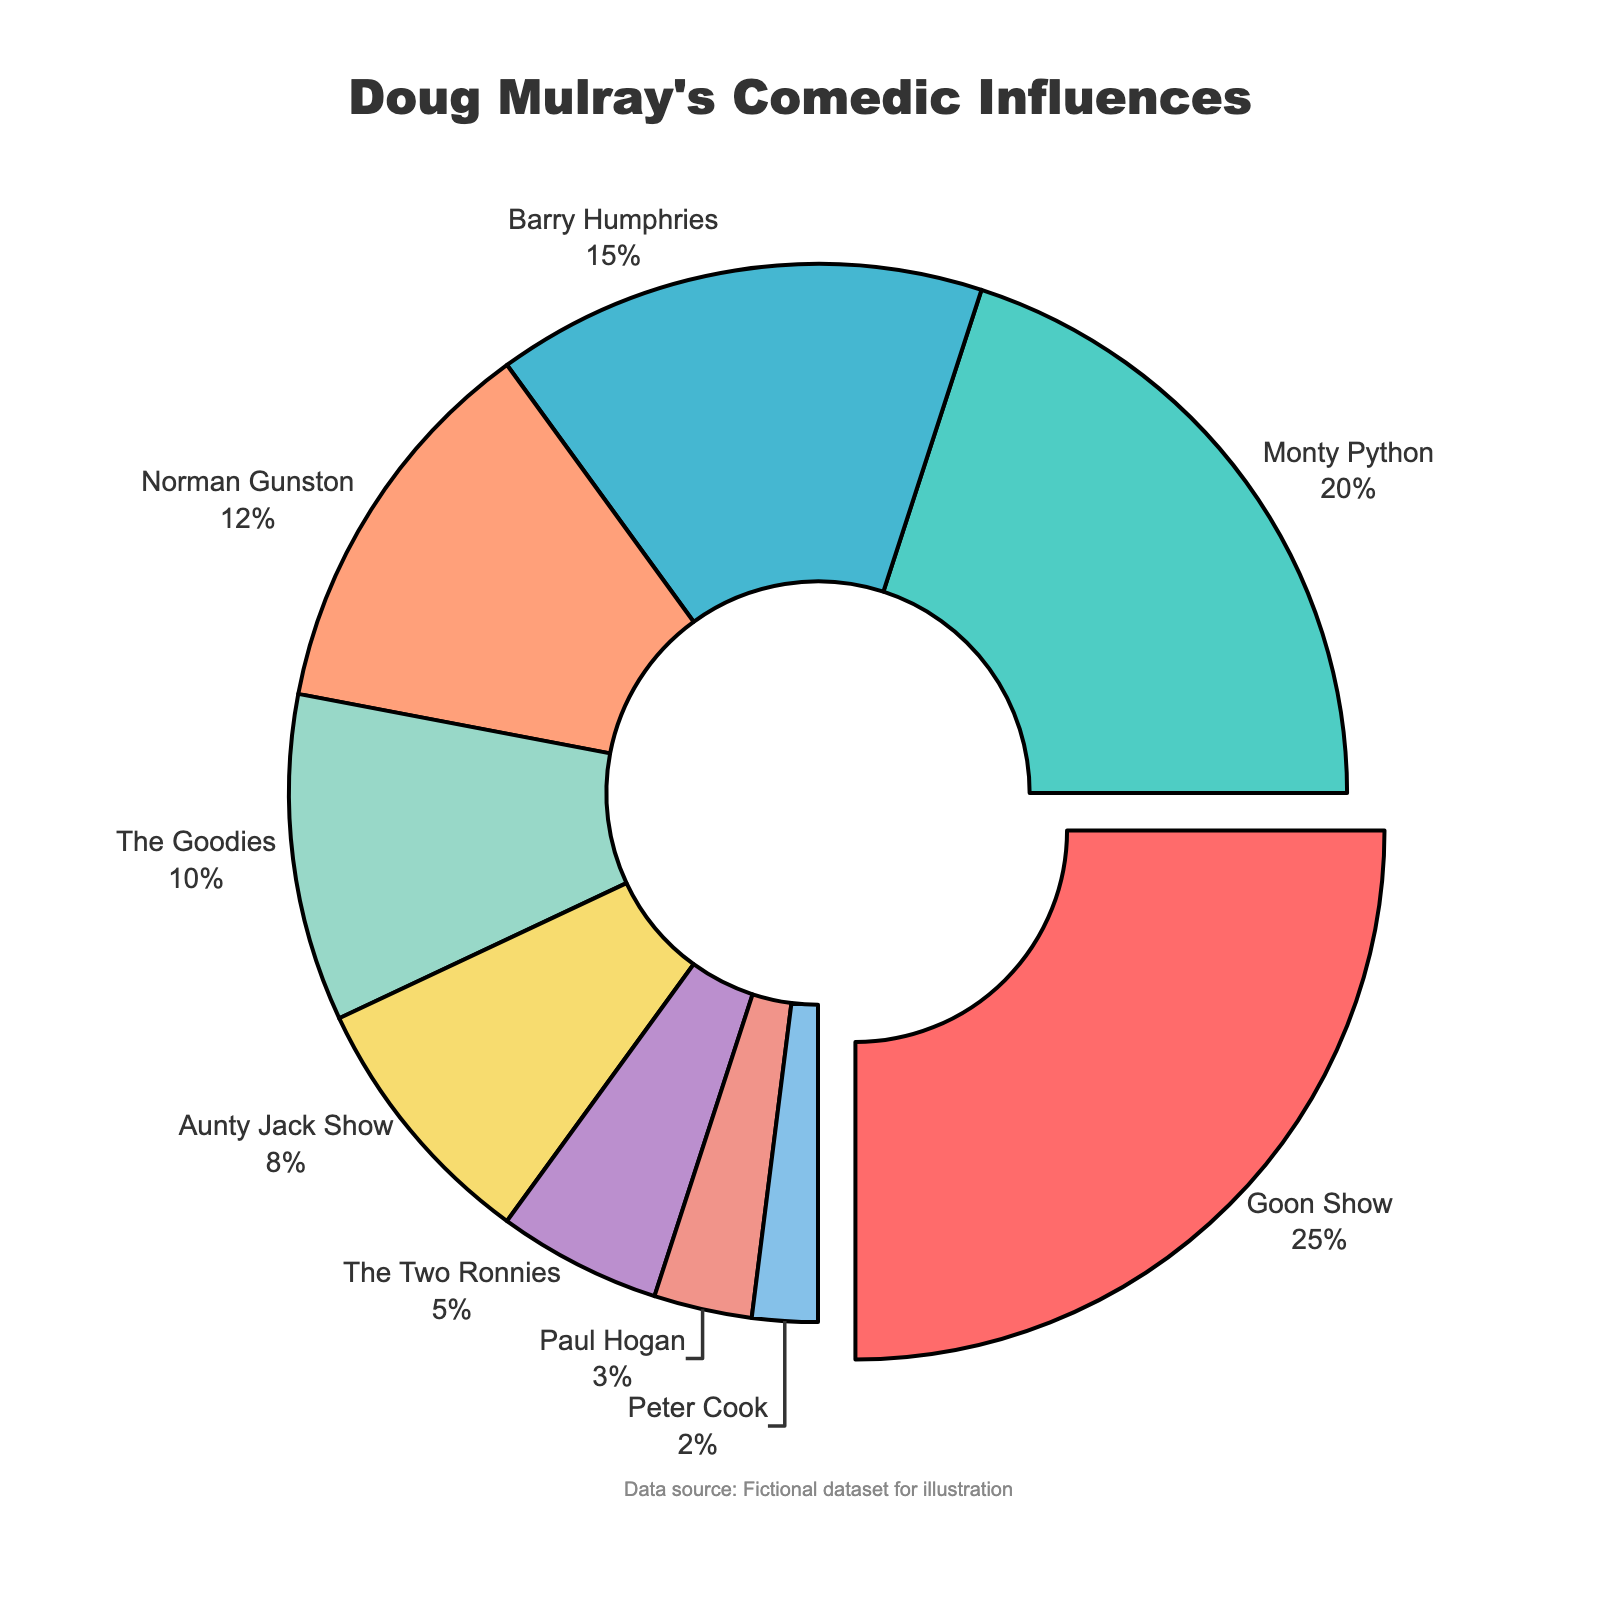What percentage of Doug Mulray's comedic influences does Monty Python occupy? Monty Python is directly shown in the pie chart with a percentage label next to it.
Answer: 20% What is the combined percentage of influences from The Goodies and Aunty Jack Show? The percentage for The Goodies is 10% and for Aunty Jack Show is 8%. Adding them together gives 10% + 8% = 18%.
Answer: 18% Which comedic influence occupies the highest percentage in Doug Mulray's comedic influences? The pie chart shows a "pull" effect on the segment with the highest percentage. The Goon Show segment is visibly pulled out and labeled with 25%.
Answer: Goon Show By how much does the percentage of Barry Humphries exceed the percentage of Paul Hogan? Barry Humphries has 15% while Paul Hogan has 3%. Subtracting these values gives 15% - 3% = 12%.
Answer: 12% Are the combined percentages of Norman Gunston and The Two Ronnies equal to the percentage of Barry Humphries? The percentage of Norman Gunston is 12% and The Two Ronnies is 5%. Adding them together gives 12% + 5% = 17%. Comparing this to Barry Humphries' 15%, 17% is not equal to 15%.
Answer: No Which comedic influences have a percentage greater than 10%? The pie chart shows the percentages for all influences. The segments with more than 10% are Goon Show (25%), Monty Python (20%), Barry Humphries (15%), and Norman Gunston (12%).
Answer: Goon Show, Monty Python, Barry Humphries, Norman Gunston Which comedic influence has the smallest share, and what is its percentage? The pie chart lists Peter Cook with a 2% share, which is the smallest value.
Answer: Peter Cook, 2% What is the total percentage of comedic influences that have less than 10% share? Adding the percentages of The Goodies (10%), Aunty Jack Show (8%), The Two Ronnies (5%), Paul Hogan (3%), and Peter Cook (2%) gives 10% + 8% + 5% + 3% + 2% = 28%.
Answer: 28% Does the percentage of influence from Monty Python exceed the combined percentage of The Two Ronnies and Paul Hogan? The percentage for Monty Python is 20%. The combined percentage for The Two Ronnies and Paul Hogan is 5% + 3% = 8%. Since 20% > 8%, Monty Python's percentage exceeds.
Answer: Yes 